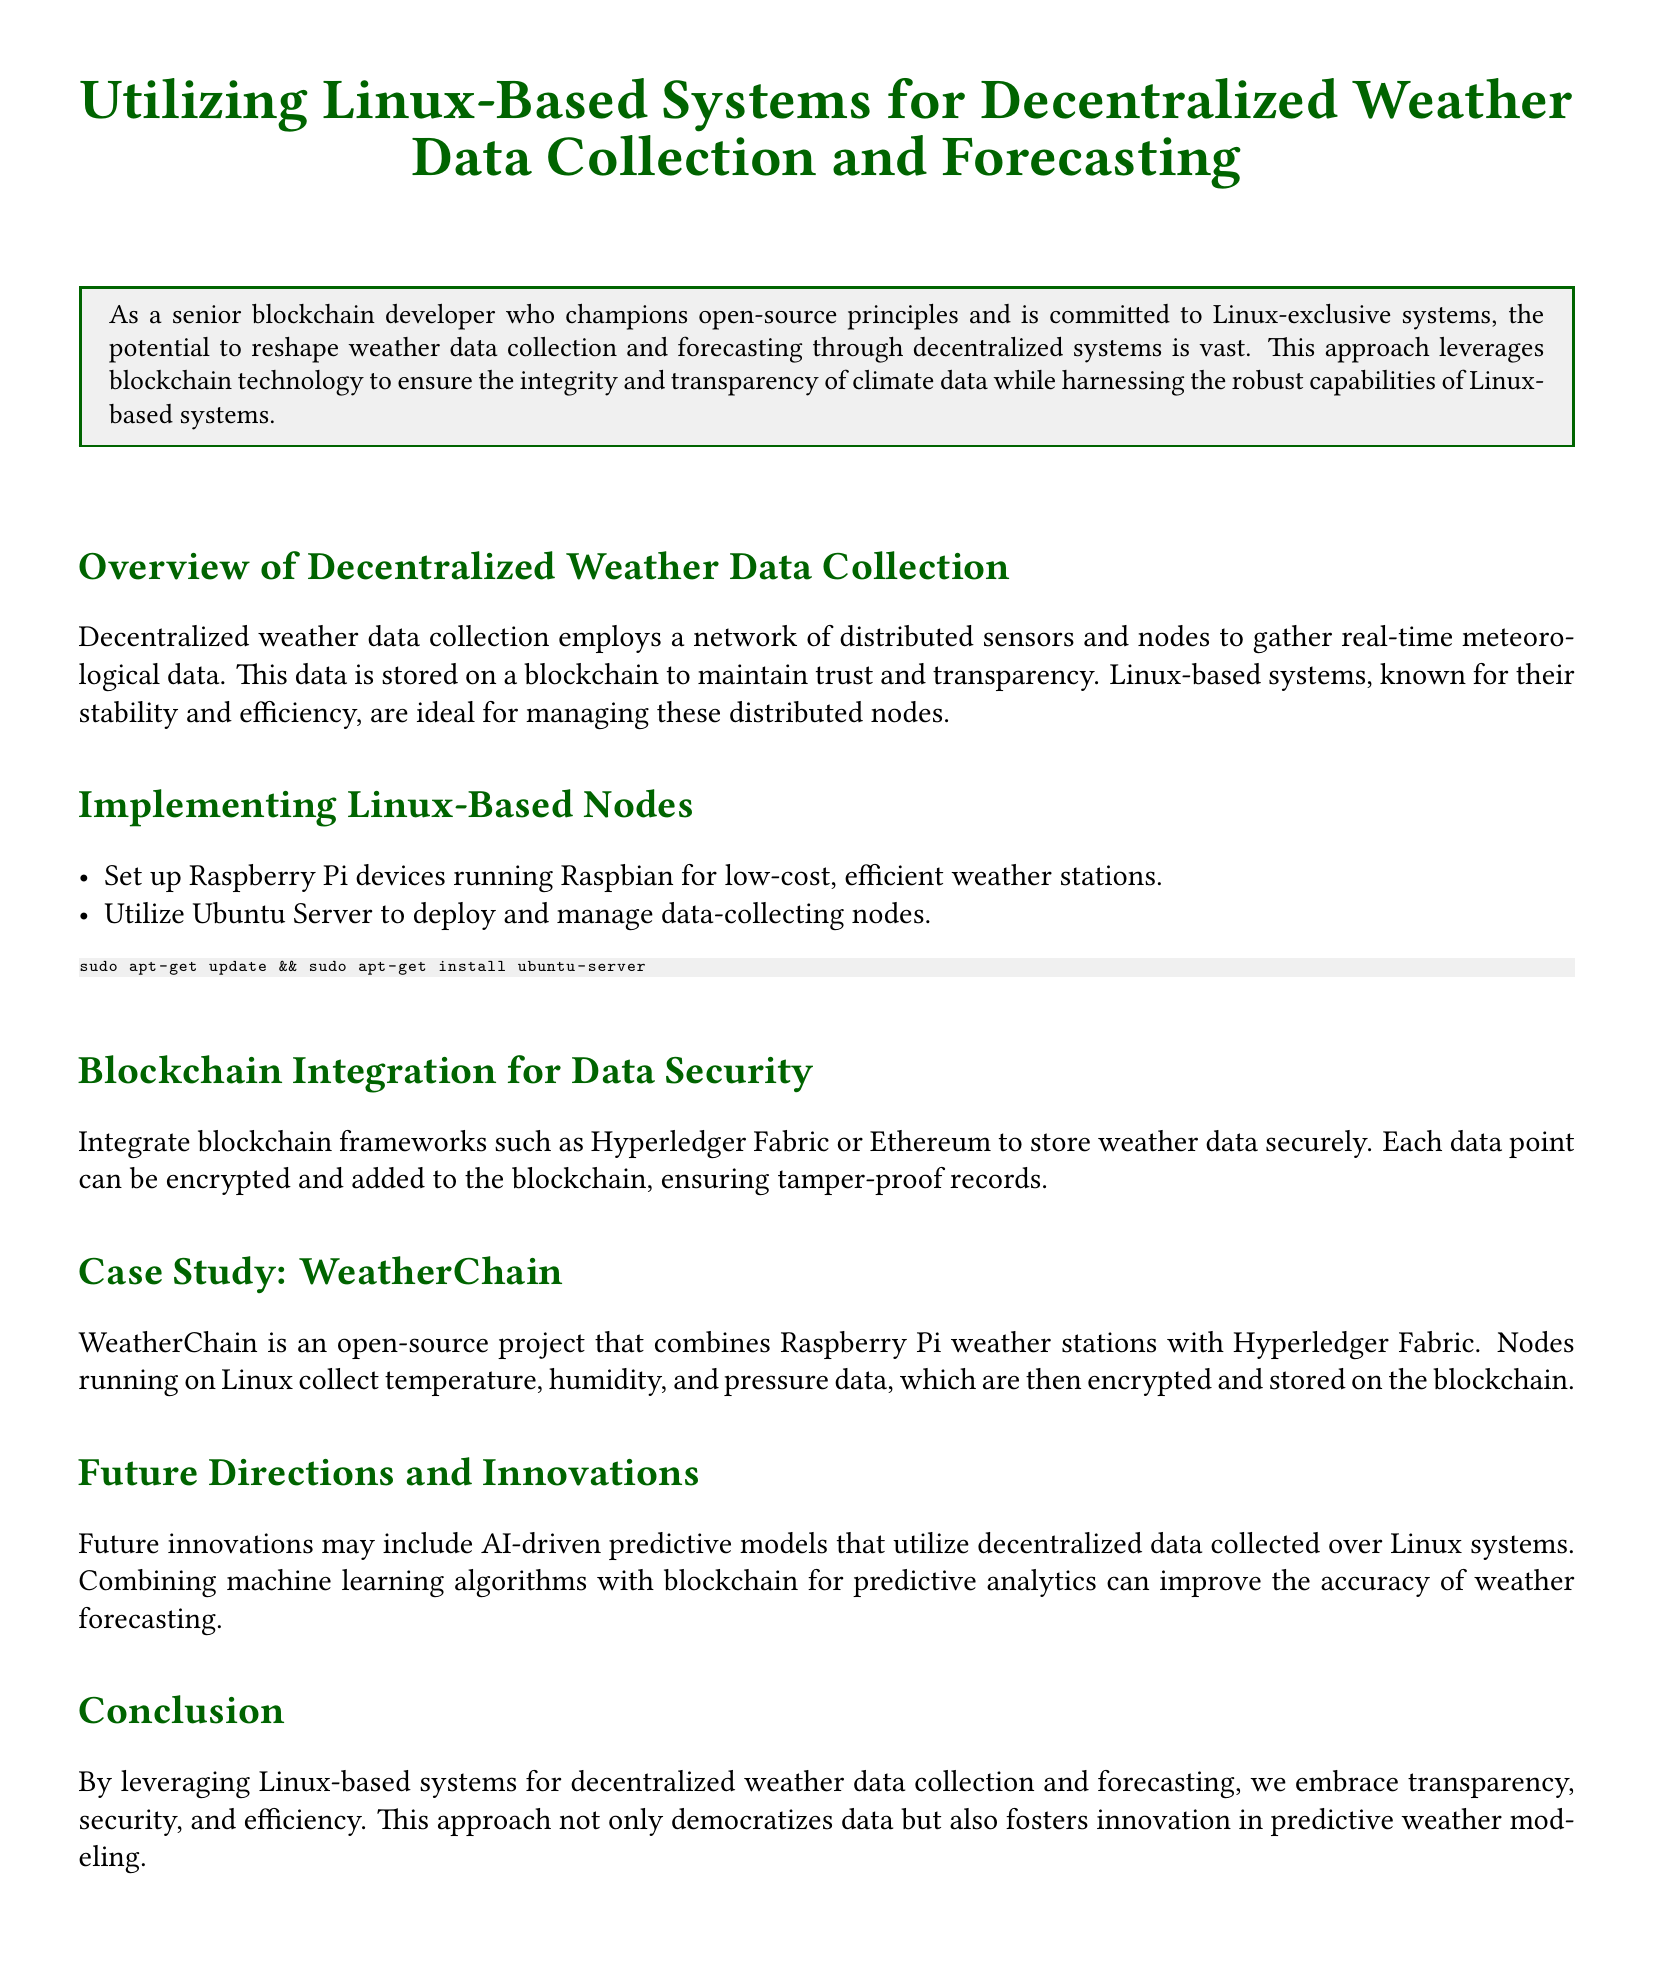What is the main focus of the document? The main focus is on using Linux-based systems for decentralized weather data collection and forecasting.
Answer: Linux-based systems for decentralized weather data collection and forecasting What low-cost device is suggested for weather stations? The document suggests using Raspberry Pi devices for low-cost weather stations.
Answer: Raspberry Pi What blockchain framework is mentioned for data security? The document mentions Hyperledger Fabric as a blockchain framework for storing weather data securely.
Answer: Hyperledger Fabric What type of operating system is used to deploy and manage data-collecting nodes? The document states that Ubuntu Server is utilized for deploying and managing data-collecting nodes.
Answer: Ubuntu Server What is the name of the case study project discussed? The case study project discussed in the document is called WeatherChain.
Answer: WeatherChain How does the document describe the future of weather forecasting technology? The document suggests that future innovations may include AI-driven predictive models using decentralized data.
Answer: AI-driven predictive models What role does blockchain play in weather data collection according to the document? The document states that blockchain ensures tamper-proof records of weather data.
Answer: Tamper-proof records What is the significance of Linux systems in this context? The document highlights that Linux systems are known for their stability and efficiency in managing distributed nodes.
Answer: Stability and efficiency What meteorological data is collected by the WeatherChain nodes? The document specifies that temperature, humidity, and pressure data are collected by WeatherChain nodes.
Answer: Temperature, humidity, and pressure data 